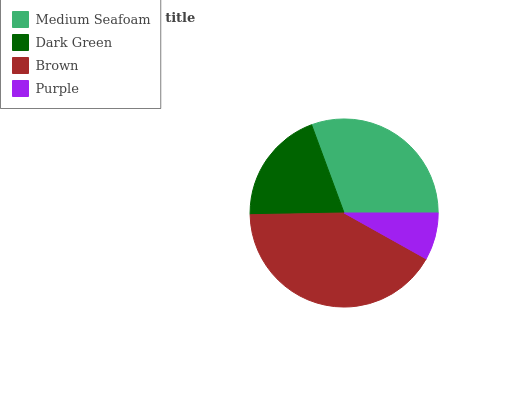Is Purple the minimum?
Answer yes or no. Yes. Is Brown the maximum?
Answer yes or no. Yes. Is Dark Green the minimum?
Answer yes or no. No. Is Dark Green the maximum?
Answer yes or no. No. Is Medium Seafoam greater than Dark Green?
Answer yes or no. Yes. Is Dark Green less than Medium Seafoam?
Answer yes or no. Yes. Is Dark Green greater than Medium Seafoam?
Answer yes or no. No. Is Medium Seafoam less than Dark Green?
Answer yes or no. No. Is Medium Seafoam the high median?
Answer yes or no. Yes. Is Dark Green the low median?
Answer yes or no. Yes. Is Dark Green the high median?
Answer yes or no. No. Is Medium Seafoam the low median?
Answer yes or no. No. 